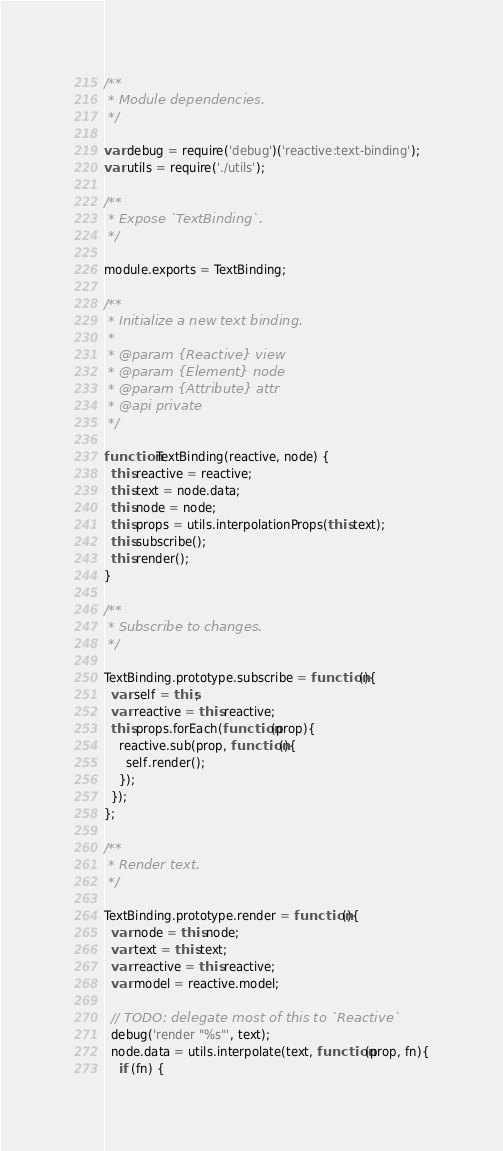<code> <loc_0><loc_0><loc_500><loc_500><_JavaScript_>
/**
 * Module dependencies.
 */

var debug = require('debug')('reactive:text-binding');
var utils = require('./utils');

/**
 * Expose `TextBinding`.
 */

module.exports = TextBinding;

/**
 * Initialize a new text binding.
 *
 * @param {Reactive} view
 * @param {Element} node
 * @param {Attribute} attr
 * @api private
 */

function TextBinding(reactive, node) {
  this.reactive = reactive;
  this.text = node.data;
  this.node = node;
  this.props = utils.interpolationProps(this.text);
  this.subscribe();
  this.render();
}

/**
 * Subscribe to changes.
 */

TextBinding.prototype.subscribe = function(){
  var self = this;
  var reactive = this.reactive;
  this.props.forEach(function(prop){
    reactive.sub(prop, function(){
      self.render();
    });
  });
};

/**
 * Render text.
 */

TextBinding.prototype.render = function(){
  var node = this.node;
  var text = this.text;
  var reactive = this.reactive;
  var model = reactive.model;

  // TODO: delegate most of this to `Reactive`
  debug('render "%s"', text);
  node.data = utils.interpolate(text, function(prop, fn){
    if (fn) {</code> 